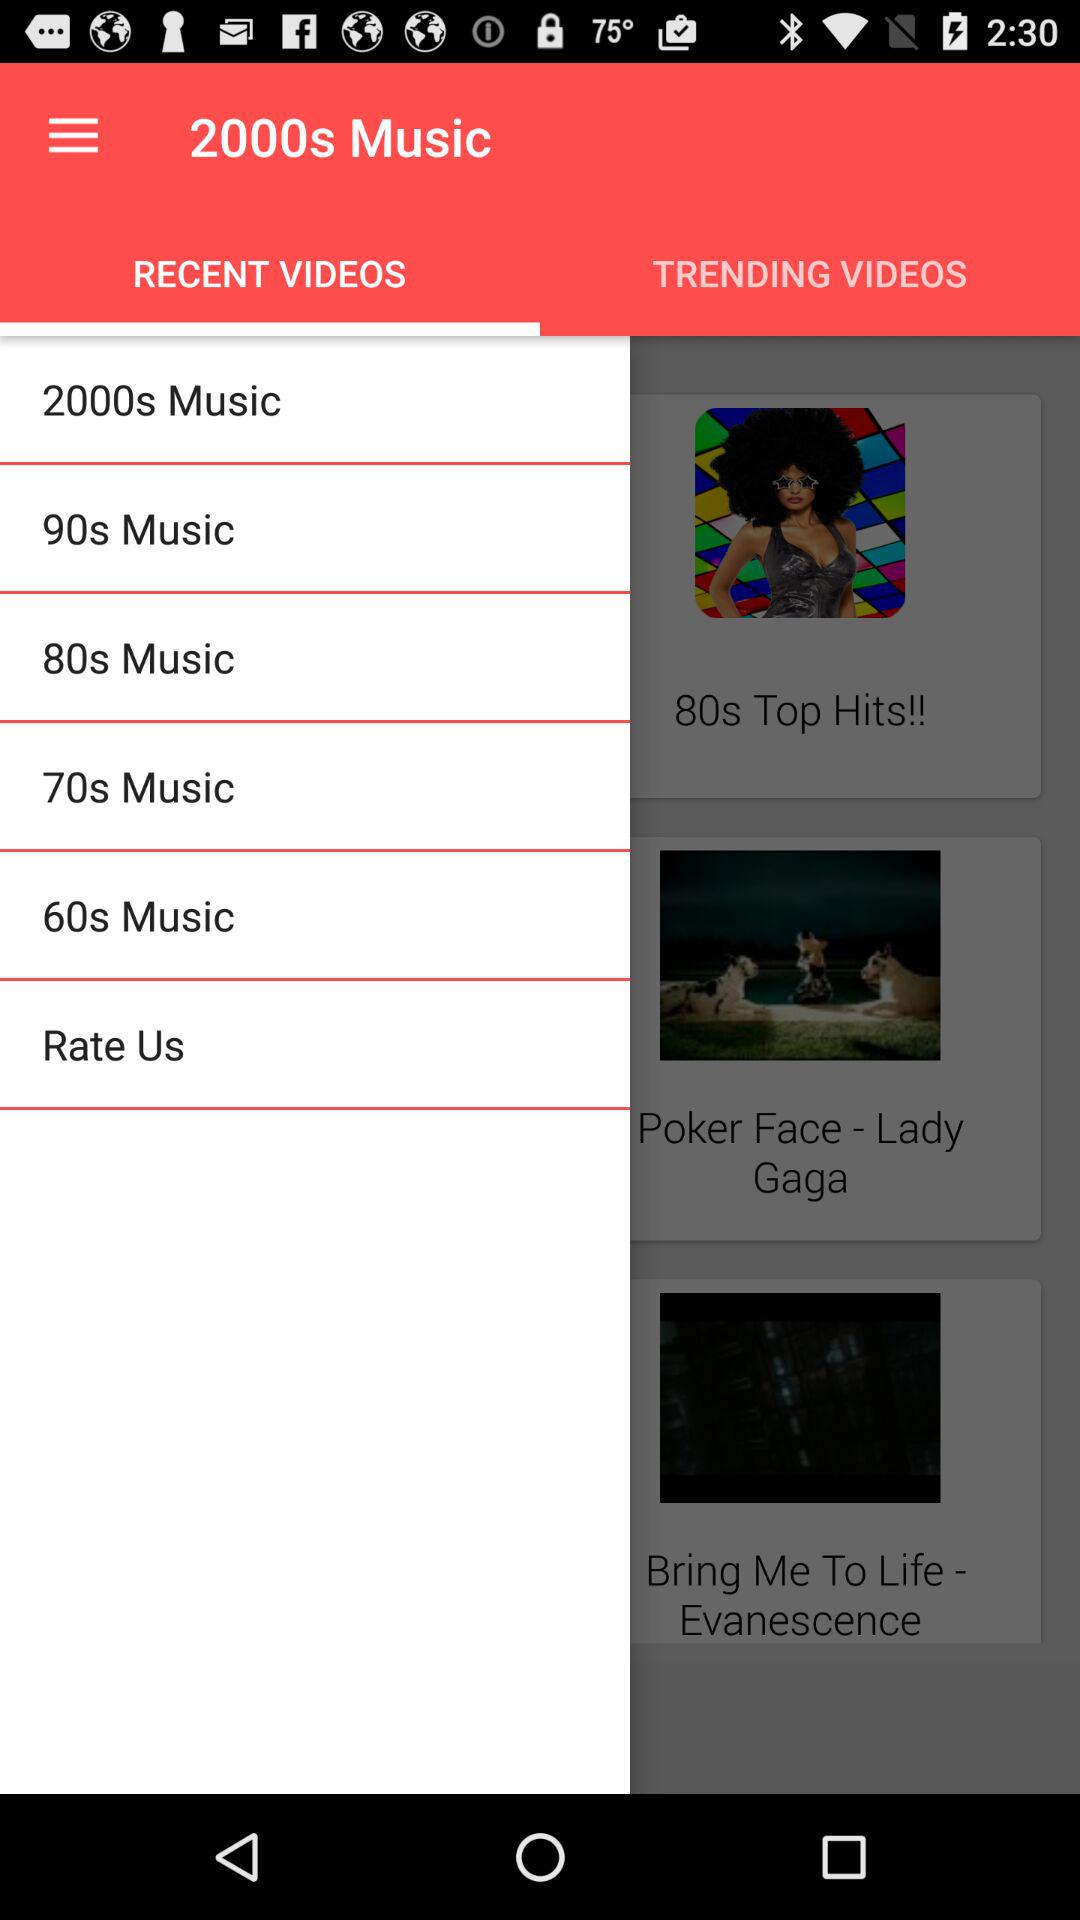What are some notable features of the trending videos section? The 'Trending Videos' section of the app depicted in the image features thumbnail previews of popular music videos from different eras, which are likely recommended based on user popularity or recent uploads. Notable entries are for '80s Top Hits!' and tracks like 'Poker Face - Lady Gaga', showing the diversity of the content that spans multiple decades, appealing to a wide audience with varied musical tastes. 